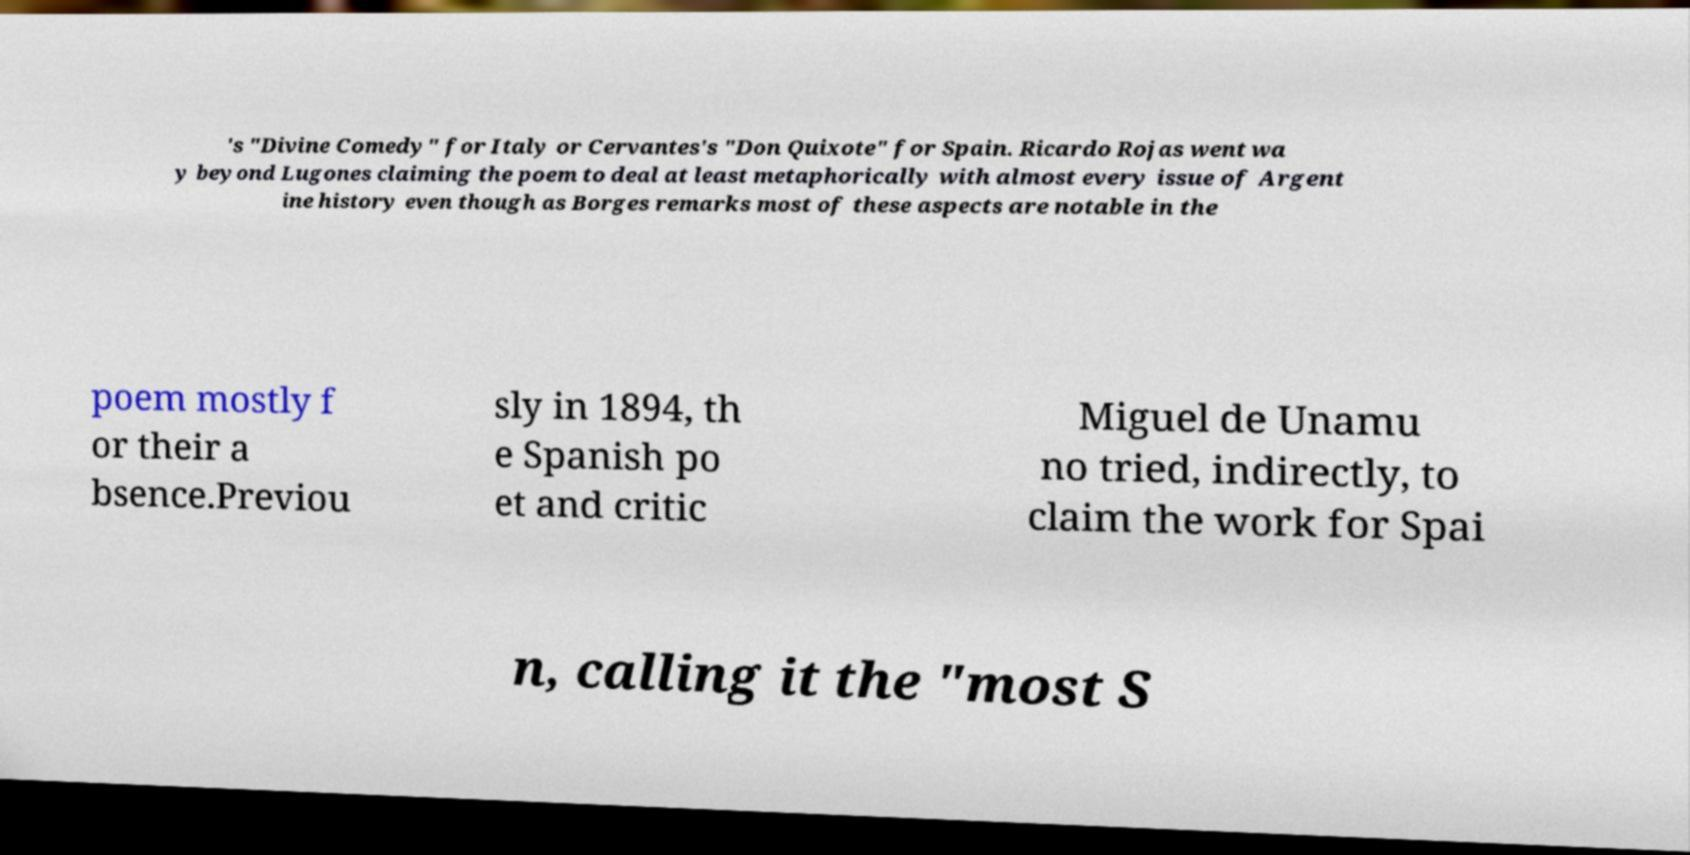Could you assist in decoding the text presented in this image and type it out clearly? 's "Divine Comedy" for Italy or Cervantes's "Don Quixote" for Spain. Ricardo Rojas went wa y beyond Lugones claiming the poem to deal at least metaphorically with almost every issue of Argent ine history even though as Borges remarks most of these aspects are notable in the poem mostly f or their a bsence.Previou sly in 1894, th e Spanish po et and critic Miguel de Unamu no tried, indirectly, to claim the work for Spai n, calling it the "most S 